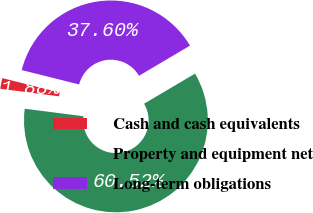Convert chart. <chart><loc_0><loc_0><loc_500><loc_500><pie_chart><fcel>Cash and cash equivalents<fcel>Property and equipment net<fcel>Long-term obligations<nl><fcel>1.88%<fcel>60.52%<fcel>37.6%<nl></chart> 